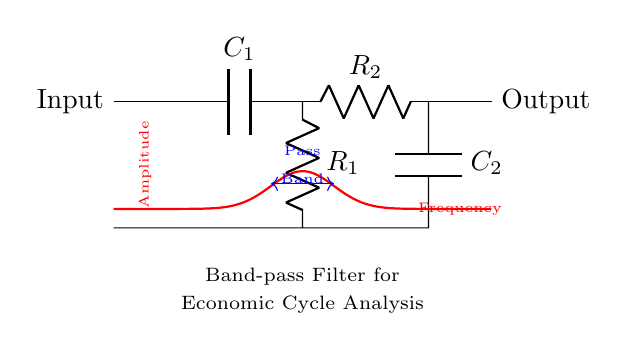What are the components of the band-pass filter? The circuit diagram contains two capacitors (C1 and C2) and two resistors (R1 and R2). These components are the basic building blocks of the filter.
Answer: Capacitors, Resistors What is the function of R1 in this filter? R1 is part of the high-pass filter section; it helps set the cutoff frequency for the frequencies that are allowed to pass, acting upon the signal after it has passed through C1.
Answer: Cuts high frequencies What is the pass band frequency range indicated in the diagram? The diagram does not provide specific numerical values for the frequency range; instead, it visually represents the area between the two arrows where frequencies pass.
Answer: Not specified How does a band-pass filter differ from a low-pass filter? A band-pass filter allows a specific range of frequencies to pass, whereas a low-pass filter only allows frequencies below a certain cutoff frequency to pass. This circuit has both high-pass and low-pass characteristics.
Answer: Pass specific range What effects do C2 and R2 have in the circuit? C2 and R2 form the low-pass filter section, where C2 stores charge and R2 influences the response to lower frequencies, determining the higher cutoff frequency for which signals remain.
Answer: Determine pass lower frequencies 